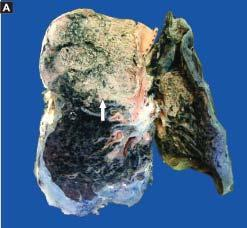what is composed of neutrophils and macrophages?
Answer the question using a single word or phrase. The infiltrate in the lumina macrophages 